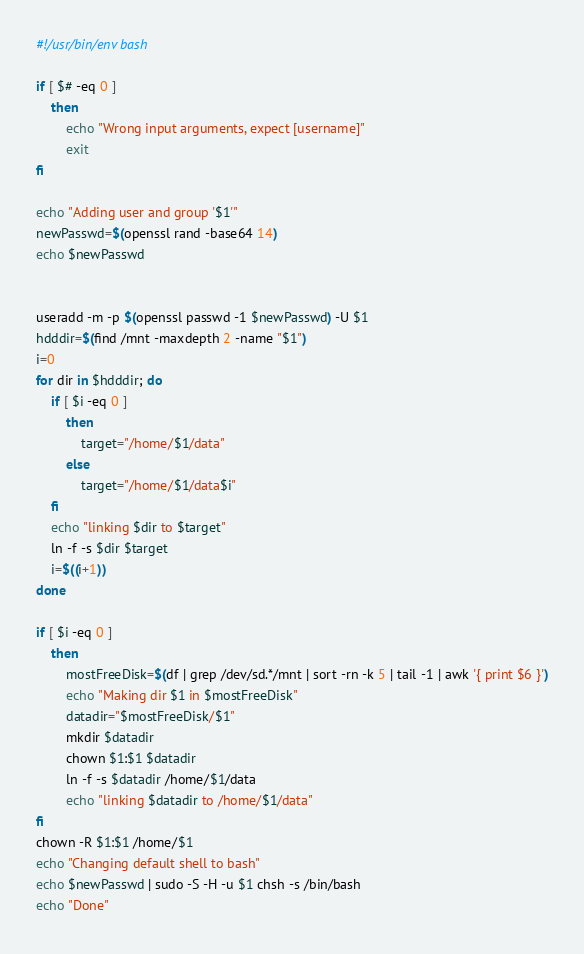<code> <loc_0><loc_0><loc_500><loc_500><_Bash_>#!/usr/bin/env bash

if [ $# -eq 0 ]
    then
        echo "Wrong input arguments, expect [username]"
        exit
fi

echo "Adding user and group '$1'"
newPasswd=$(openssl rand -base64 14)
echo $newPasswd


useradd -m -p $(openssl passwd -1 $newPasswd) -U $1
hdddir=$(find /mnt -maxdepth 2 -name "$1")
i=0
for dir in $hdddir; do
    if [ $i -eq 0 ]
        then
            target="/home/$1/data"
        else
            target="/home/$1/data$i"
    fi
    echo "linking $dir to $target"
    ln -f -s $dir $target
    i=$((i+1))
done

if [ $i -eq 0 ]
    then
        mostFreeDisk=$(df | grep /dev/sd.*/mnt | sort -rn -k 5 | tail -1 | awk '{ print $6 }')
        echo "Making dir $1 in $mostFreeDisk"
        datadir="$mostFreeDisk/$1"
        mkdir $datadir
        chown $1:$1 $datadir
        ln -f -s $datadir /home/$1/data
        echo "linking $datadir to /home/$1/data"
fi
chown -R $1:$1 /home/$1
echo "Changing default shell to bash"
echo $newPasswd | sudo -S -H -u $1 chsh -s /bin/bash
echo "Done"
</code> 